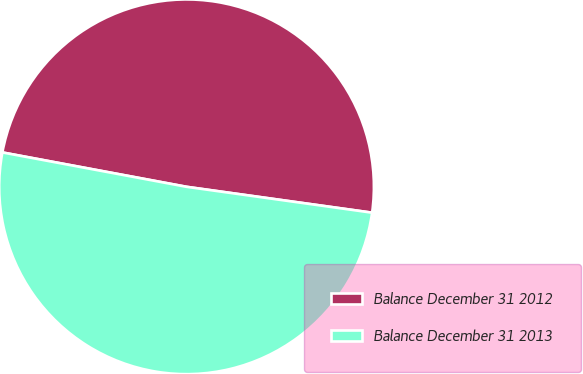<chart> <loc_0><loc_0><loc_500><loc_500><pie_chart><fcel>Balance December 31 2012<fcel>Balance December 31 2013<nl><fcel>49.27%<fcel>50.73%<nl></chart> 